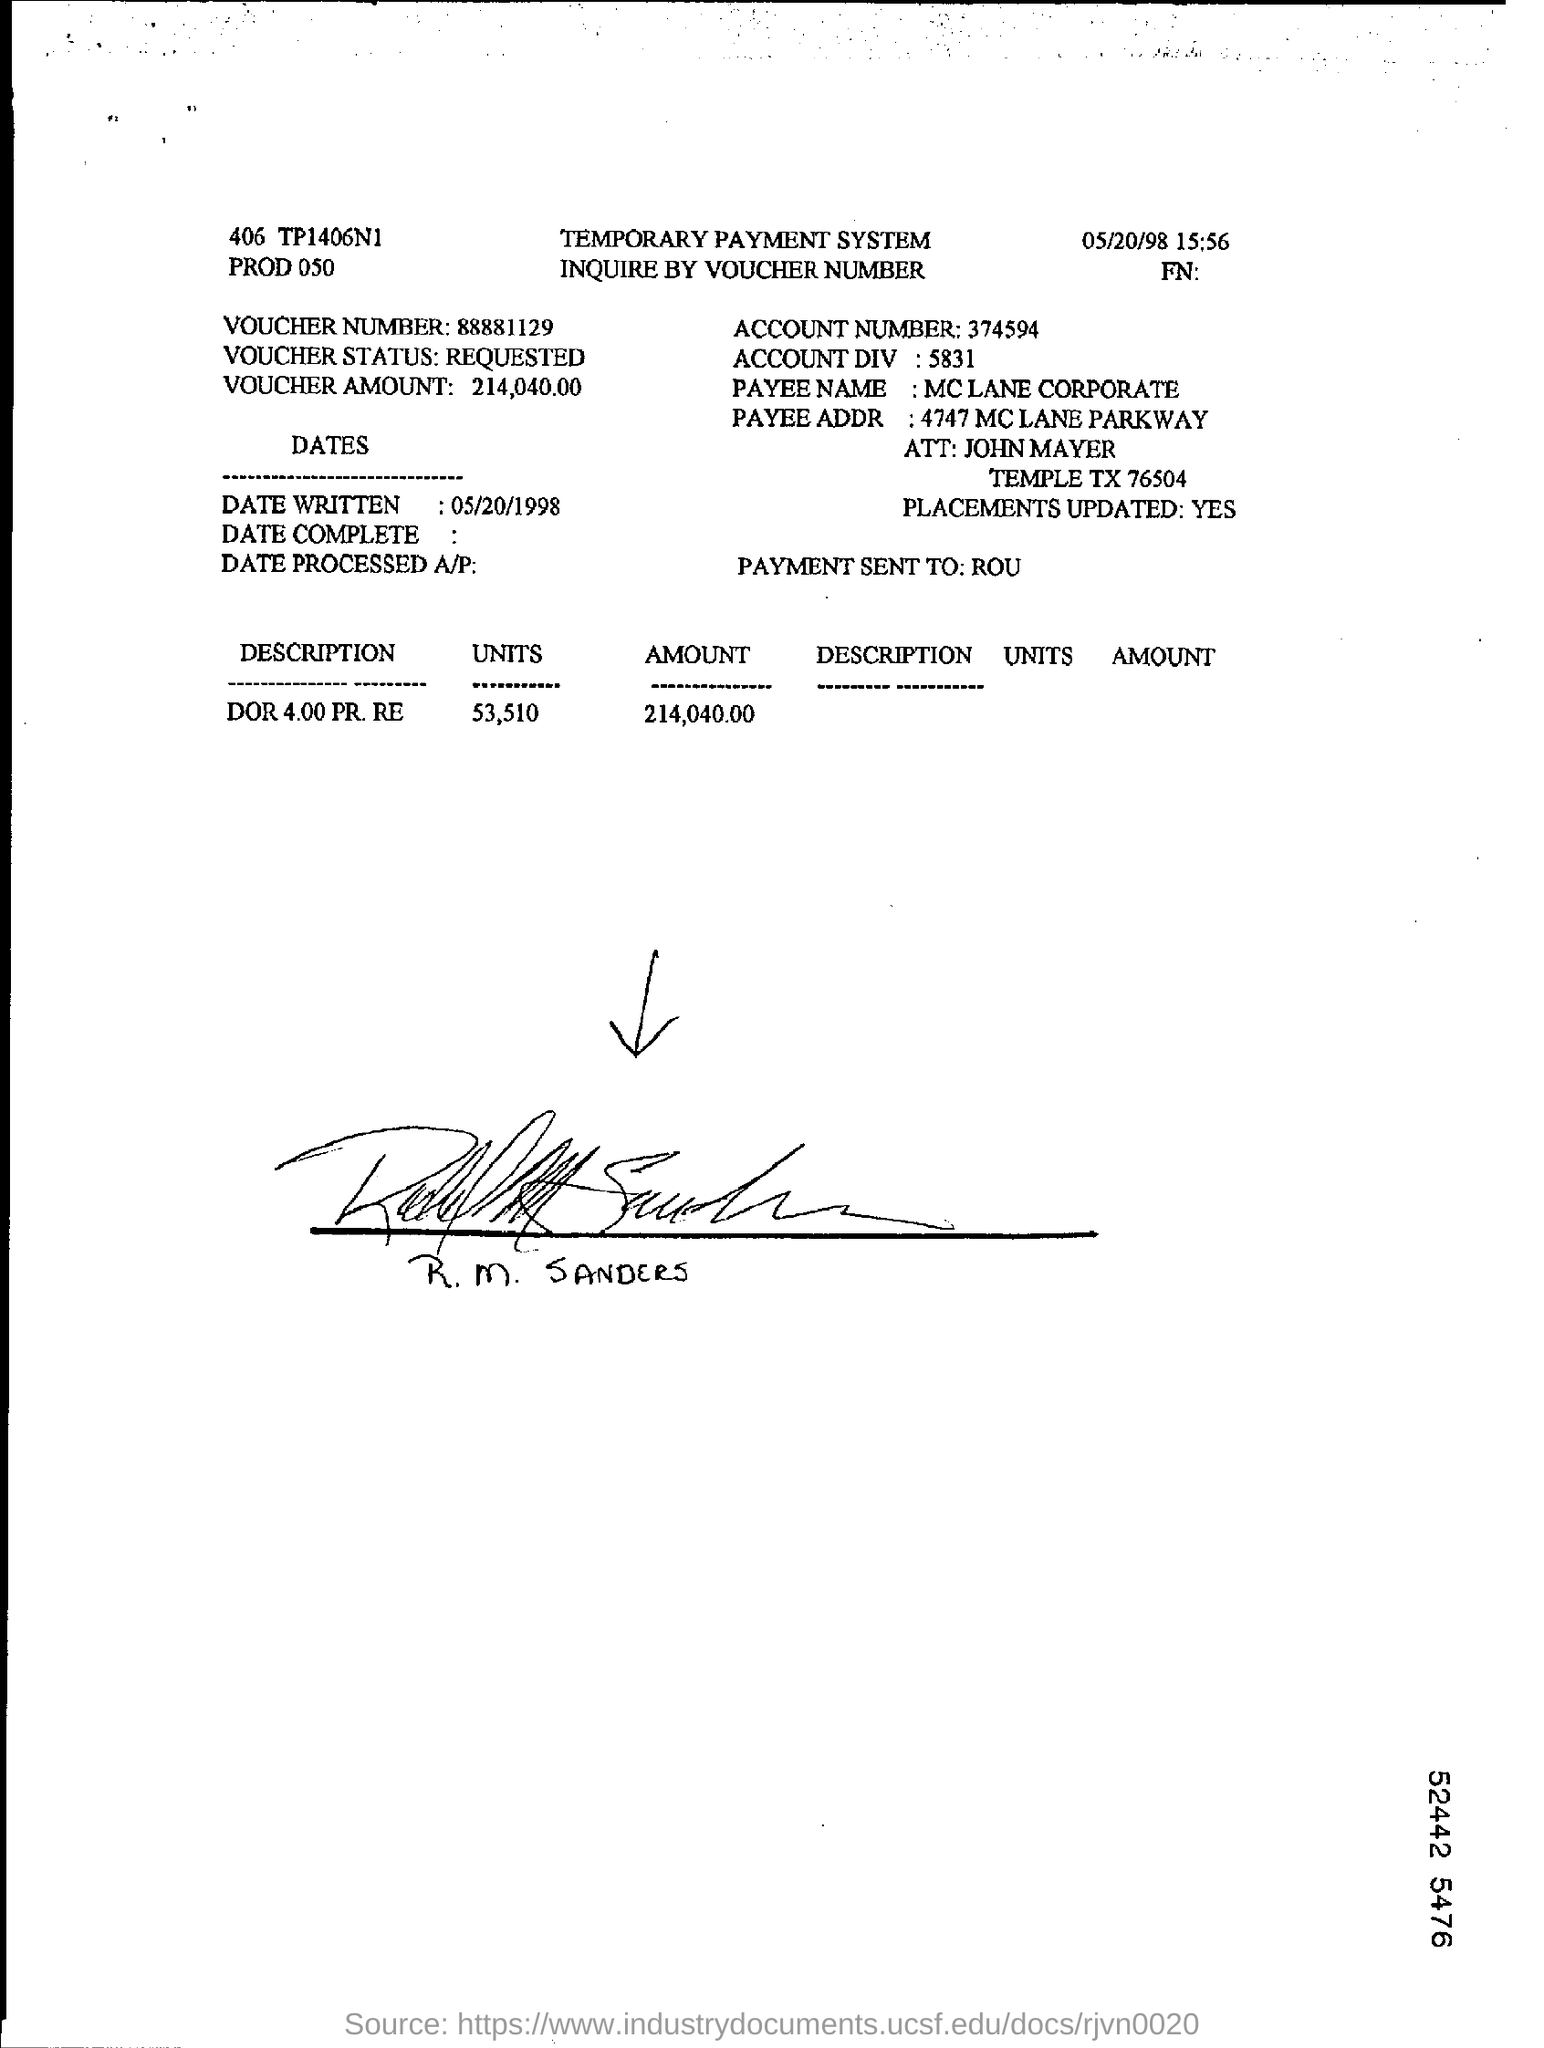What is the voucher status?
Make the answer very short. Requested. What is account number?
Provide a short and direct response. 374594. What is the amount?
Give a very brief answer. 214,040.00. Payment sent to whom?
Offer a terse response. ROU. What is the written date?
Offer a very short reply. 05/20/1998. What is the payees name?
Ensure brevity in your answer.  MC LANE CORPORATE. 